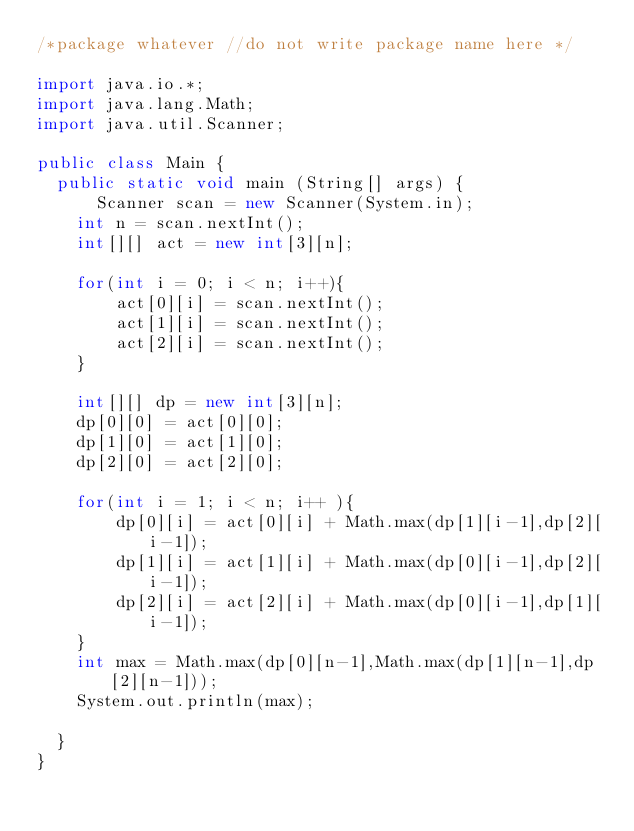<code> <loc_0><loc_0><loc_500><loc_500><_Java_>/*package whatever //do not write package name here */

import java.io.*;
import java.lang.Math; 
import java.util.Scanner;

public class Main {
	public static void main (String[] args) {
	    Scanner scan = new Scanner(System.in);
		int n = scan.nextInt();
		int[][] act = new int[3][n];
		
		for(int i = 0; i < n; i++){
		    act[0][i] = scan.nextInt();
		    act[1][i] = scan.nextInt();
		    act[2][i] = scan.nextInt();
		}
		
		int[][] dp = new int[3][n];
		dp[0][0] = act[0][0];
		dp[1][0] = act[1][0];
		dp[2][0] = act[2][0];
		
		for(int i = 1; i < n; i++ ){
		    dp[0][i] = act[0][i] + Math.max(dp[1][i-1],dp[2][i-1]);
		    dp[1][i] = act[1][i] + Math.max(dp[0][i-1],dp[2][i-1]);
		    dp[2][i] = act[2][i] + Math.max(dp[0][i-1],dp[1][i-1]);
		}
		int max = Math.max(dp[0][n-1],Math.max(dp[1][n-1],dp[2][n-1]));
		System.out.println(max);
		
	}
}</code> 